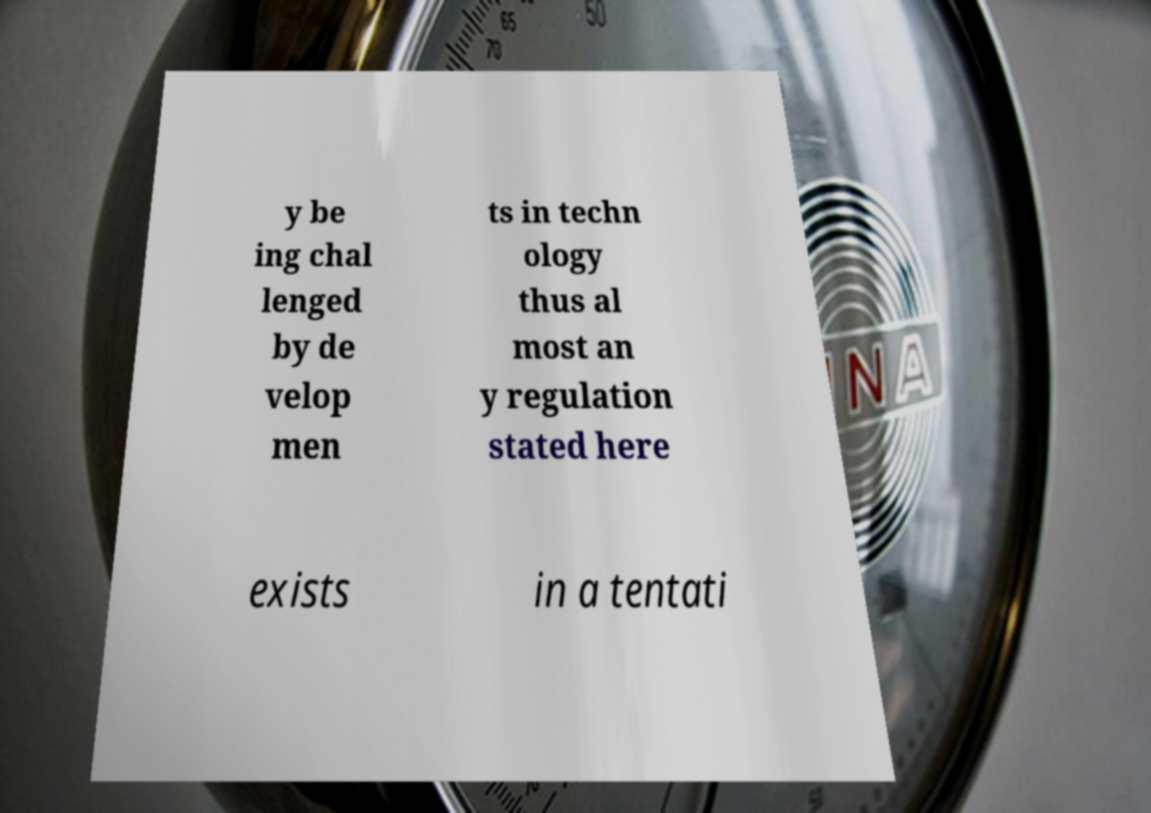I need the written content from this picture converted into text. Can you do that? y be ing chal lenged by de velop men ts in techn ology thus al most an y regulation stated here exists in a tentati 